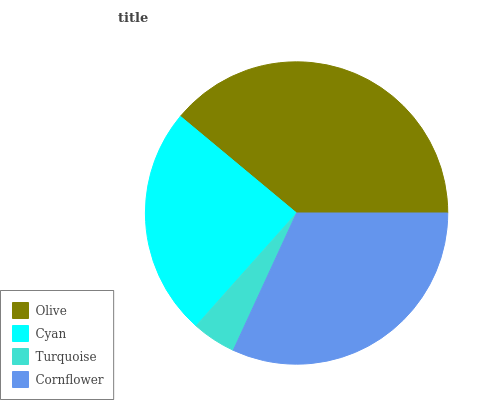Is Turquoise the minimum?
Answer yes or no. Yes. Is Olive the maximum?
Answer yes or no. Yes. Is Cyan the minimum?
Answer yes or no. No. Is Cyan the maximum?
Answer yes or no. No. Is Olive greater than Cyan?
Answer yes or no. Yes. Is Cyan less than Olive?
Answer yes or no. Yes. Is Cyan greater than Olive?
Answer yes or no. No. Is Olive less than Cyan?
Answer yes or no. No. Is Cornflower the high median?
Answer yes or no. Yes. Is Cyan the low median?
Answer yes or no. Yes. Is Cyan the high median?
Answer yes or no. No. Is Olive the low median?
Answer yes or no. No. 